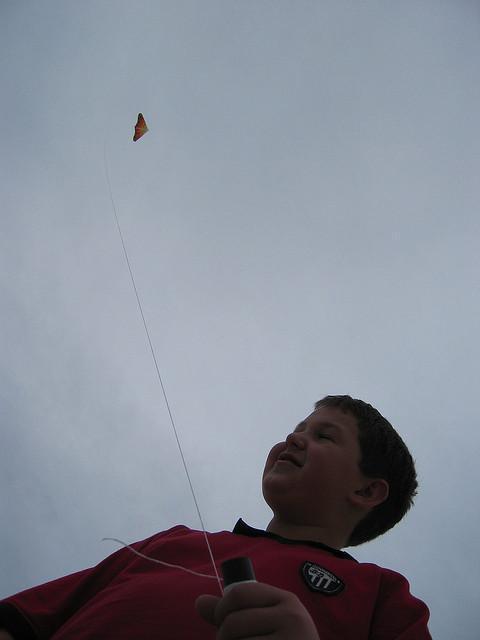How many kites are in the sky?
Give a very brief answer. 1. How many skis is the man using?
Give a very brief answer. 0. 